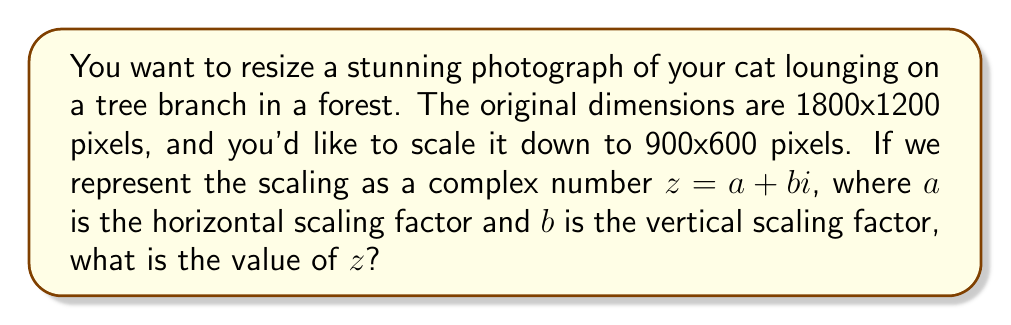Can you solve this math problem? Let's approach this step-by-step:

1) The scaling factor for the horizontal dimension is:
   $a = \frac{\text{new width}}{\text{original width}} = \frac{900}{1800} = 0.5$

2) The scaling factor for the vertical dimension is:
   $b = \frac{\text{new height}}{\text{original height}} = \frac{600}{1200} = 0.5$

3) In complex number notation, we represent this scaling as $z = a + bi$

4) Substituting our values:
   $z = 0.5 + 0.5i$

5) However, since both scaling factors are the same (0.5), we can simplify this to:
   $z = 0.5(1 + i)$

6) This complex number represents a uniform scaling by 0.5 in both dimensions.

Note: When we multiply a complex number $(x + yi)$ by $z$, it scales the real part by 0.5 and the imaginary part by 0.5, effectively scaling the entire image uniformly by half.
Answer: $z = 0.5(1 + i)$ 